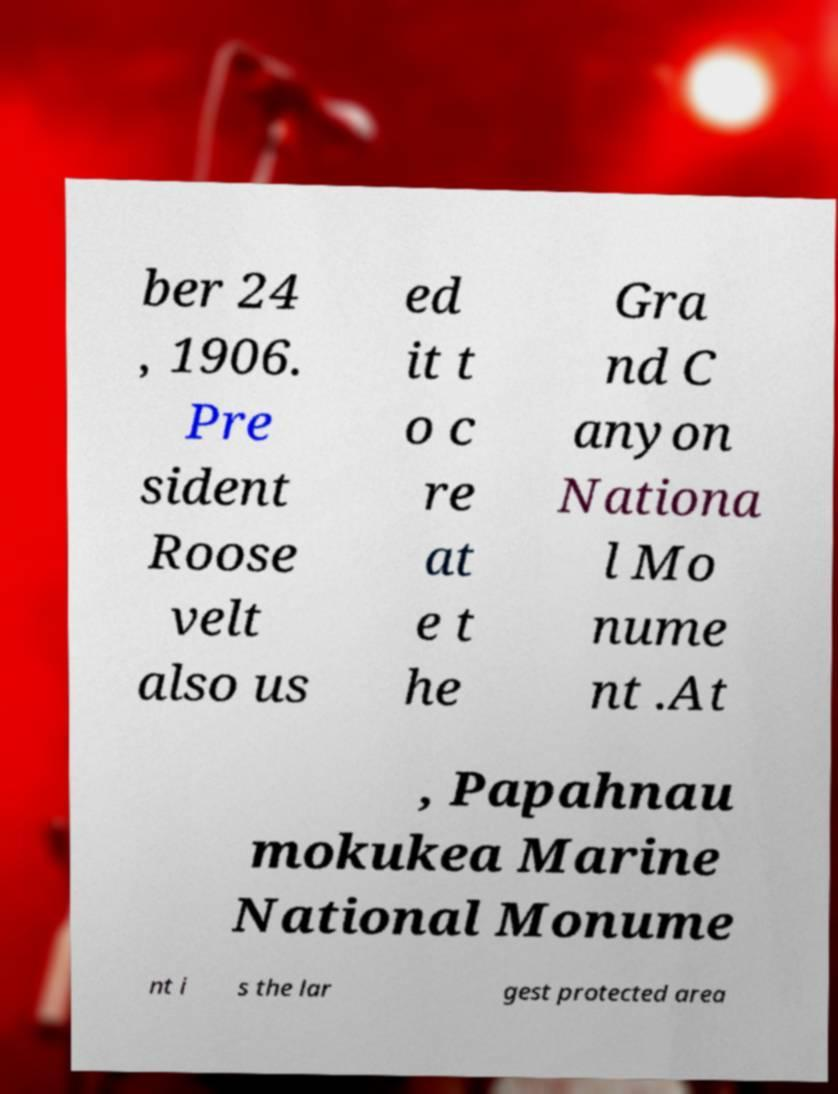What messages or text are displayed in this image? I need them in a readable, typed format. ber 24 , 1906. Pre sident Roose velt also us ed it t o c re at e t he Gra nd C anyon Nationa l Mo nume nt .At , Papahnau mokukea Marine National Monume nt i s the lar gest protected area 